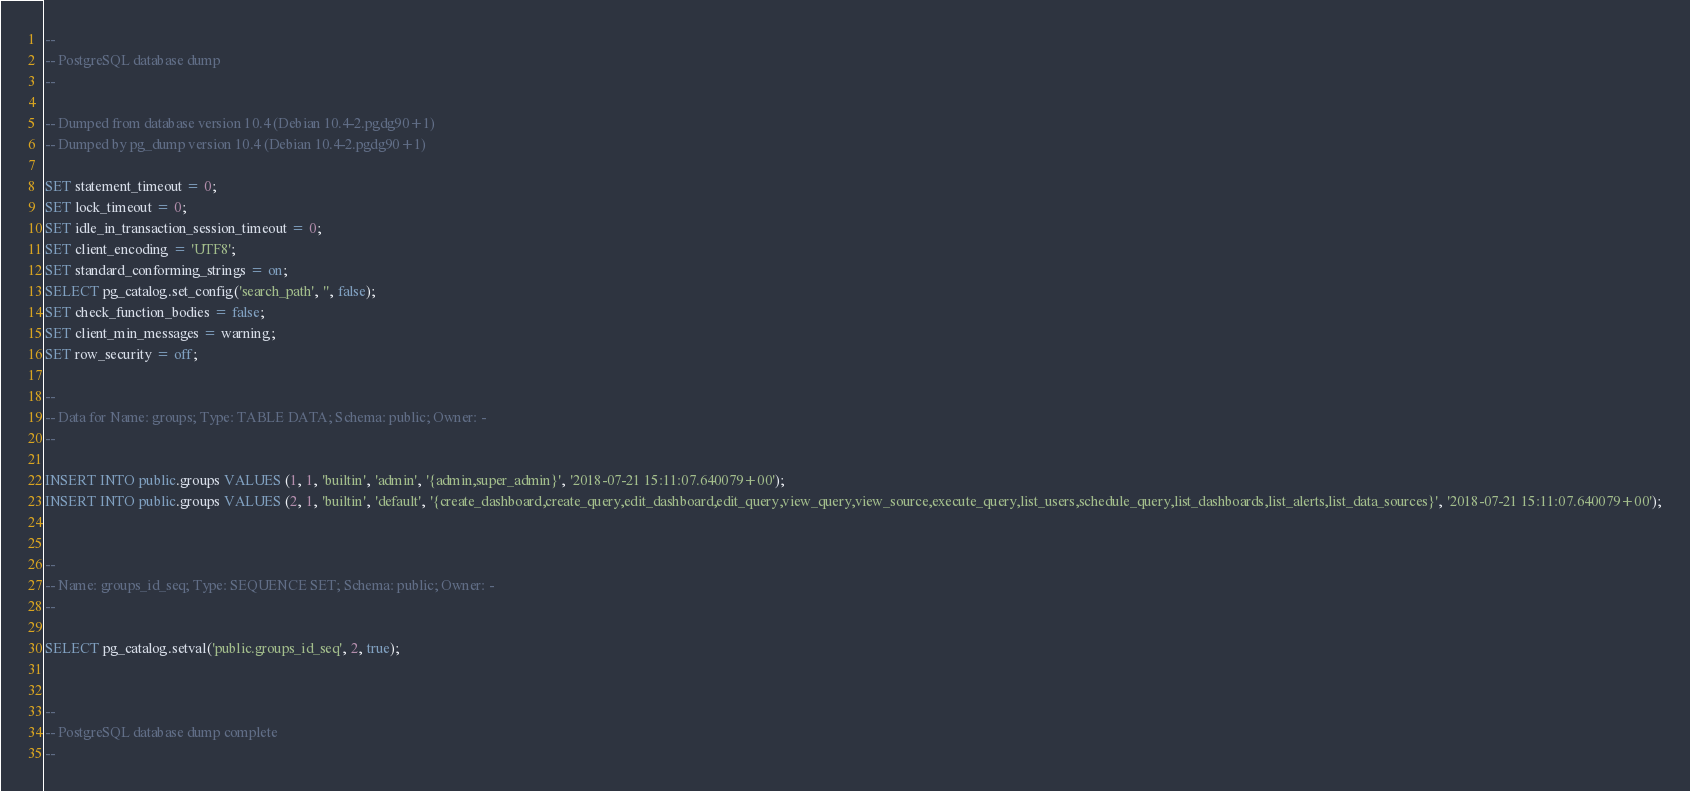Convert code to text. <code><loc_0><loc_0><loc_500><loc_500><_SQL_>--
-- PostgreSQL database dump
--

-- Dumped from database version 10.4 (Debian 10.4-2.pgdg90+1)
-- Dumped by pg_dump version 10.4 (Debian 10.4-2.pgdg90+1)

SET statement_timeout = 0;
SET lock_timeout = 0;
SET idle_in_transaction_session_timeout = 0;
SET client_encoding = 'UTF8';
SET standard_conforming_strings = on;
SELECT pg_catalog.set_config('search_path', '', false);
SET check_function_bodies = false;
SET client_min_messages = warning;
SET row_security = off;

--
-- Data for Name: groups; Type: TABLE DATA; Schema: public; Owner: -
--

INSERT INTO public.groups VALUES (1, 1, 'builtin', 'admin', '{admin,super_admin}', '2018-07-21 15:11:07.640079+00');
INSERT INTO public.groups VALUES (2, 1, 'builtin', 'default', '{create_dashboard,create_query,edit_dashboard,edit_query,view_query,view_source,execute_query,list_users,schedule_query,list_dashboards,list_alerts,list_data_sources}', '2018-07-21 15:11:07.640079+00');


--
-- Name: groups_id_seq; Type: SEQUENCE SET; Schema: public; Owner: -
--

SELECT pg_catalog.setval('public.groups_id_seq', 2, true);


--
-- PostgreSQL database dump complete
--

</code> 